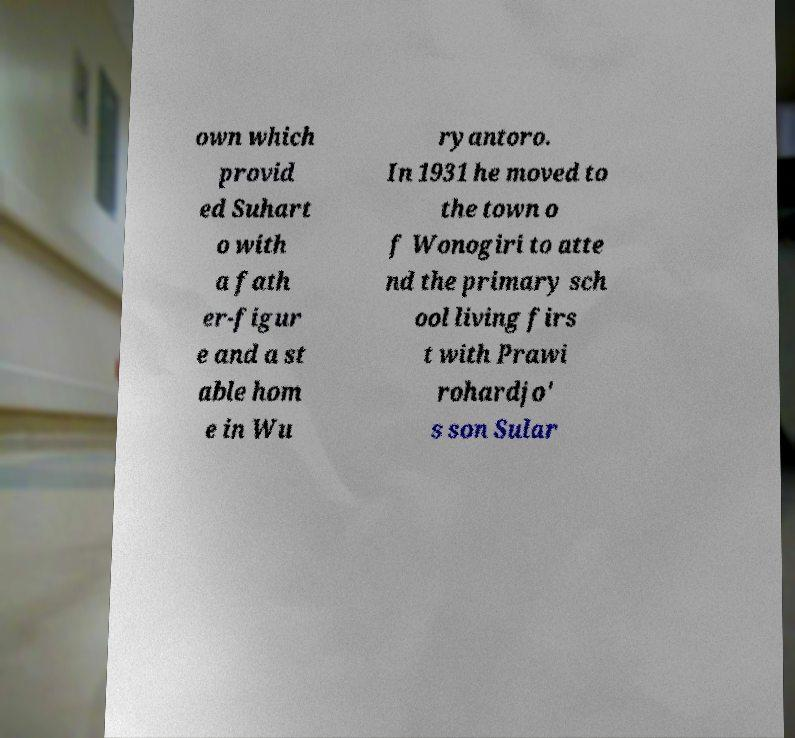Could you assist in decoding the text presented in this image and type it out clearly? own which provid ed Suhart o with a fath er-figur e and a st able hom e in Wu ryantoro. In 1931 he moved to the town o f Wonogiri to atte nd the primary sch ool living firs t with Prawi rohardjo' s son Sular 